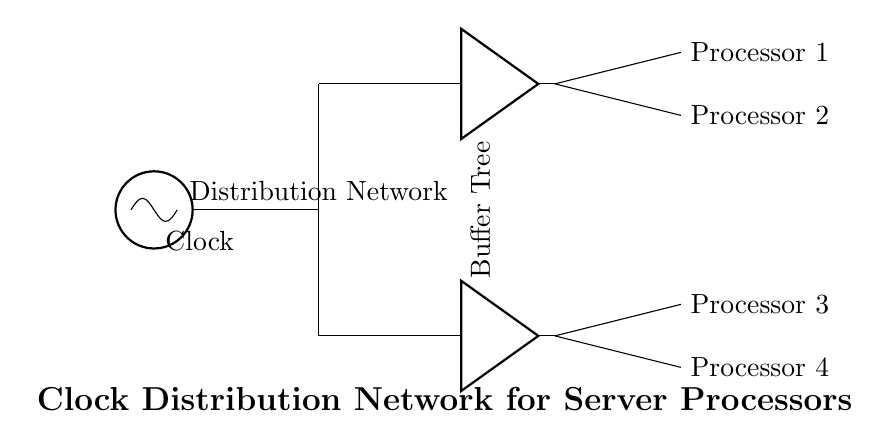What is the purpose of the clock in this circuit? The clock serves as a timing signal to synchronize the operations of the multiple processors connected to the distribution network.
Answer: Synchronization How many processors are shown in this circuit? The circuit depicts four processors, labeled as Processor 1, Processor 2, Processor 3, and Processor 4.
Answer: Four What is the function of the buffer in this distribution network? Buffers are used to amplify and isolate the clock signal as it is distributed to multiple processors, ensuring signal integrity and reducing load on the clock source.
Answer: Amplification What component directly connects to the clock source? The clock source is directly connected to the distribution network, represented as a line leading from the clock to the next section of the circuit.
Answer: Distribution network What connects both buffer nodes in the distribution network? The buffer nodes are connected through the same distribution network line, implying they are part of a tree structure that branches out to feed the processors.
Answer: Distribution network line Which processors are fed by the first buffer? Processor 1 and Processor 2 are fed by the first buffer, as indicated by the branching lines coming from that buffer node.
Answer: Processor 1 and Processor 2 